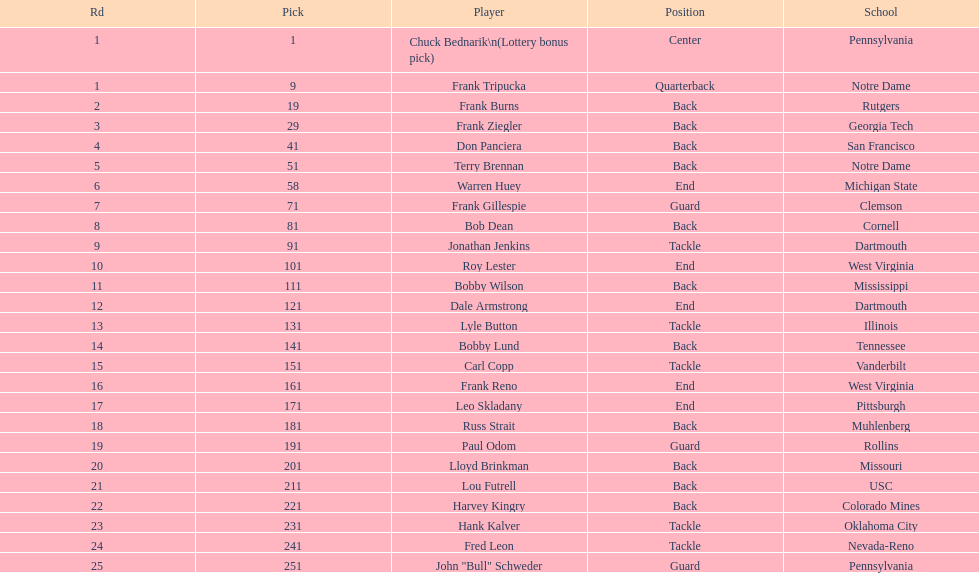Who was chosen after frank burns? Frank Ziegler. 